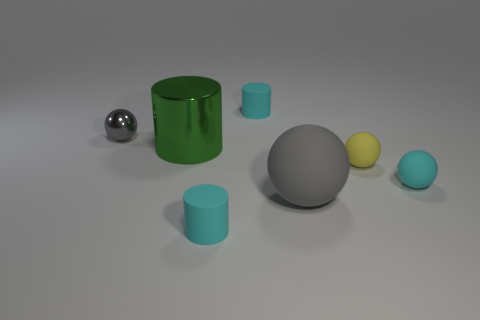Subtract all green balls. Subtract all red cylinders. How many balls are left? 4 Add 1 large brown blocks. How many objects exist? 8 Subtract all cylinders. How many objects are left? 4 Subtract 0 blue balls. How many objects are left? 7 Subtract all yellow objects. Subtract all small yellow things. How many objects are left? 5 Add 2 cylinders. How many cylinders are left? 5 Add 5 big green cylinders. How many big green cylinders exist? 6 